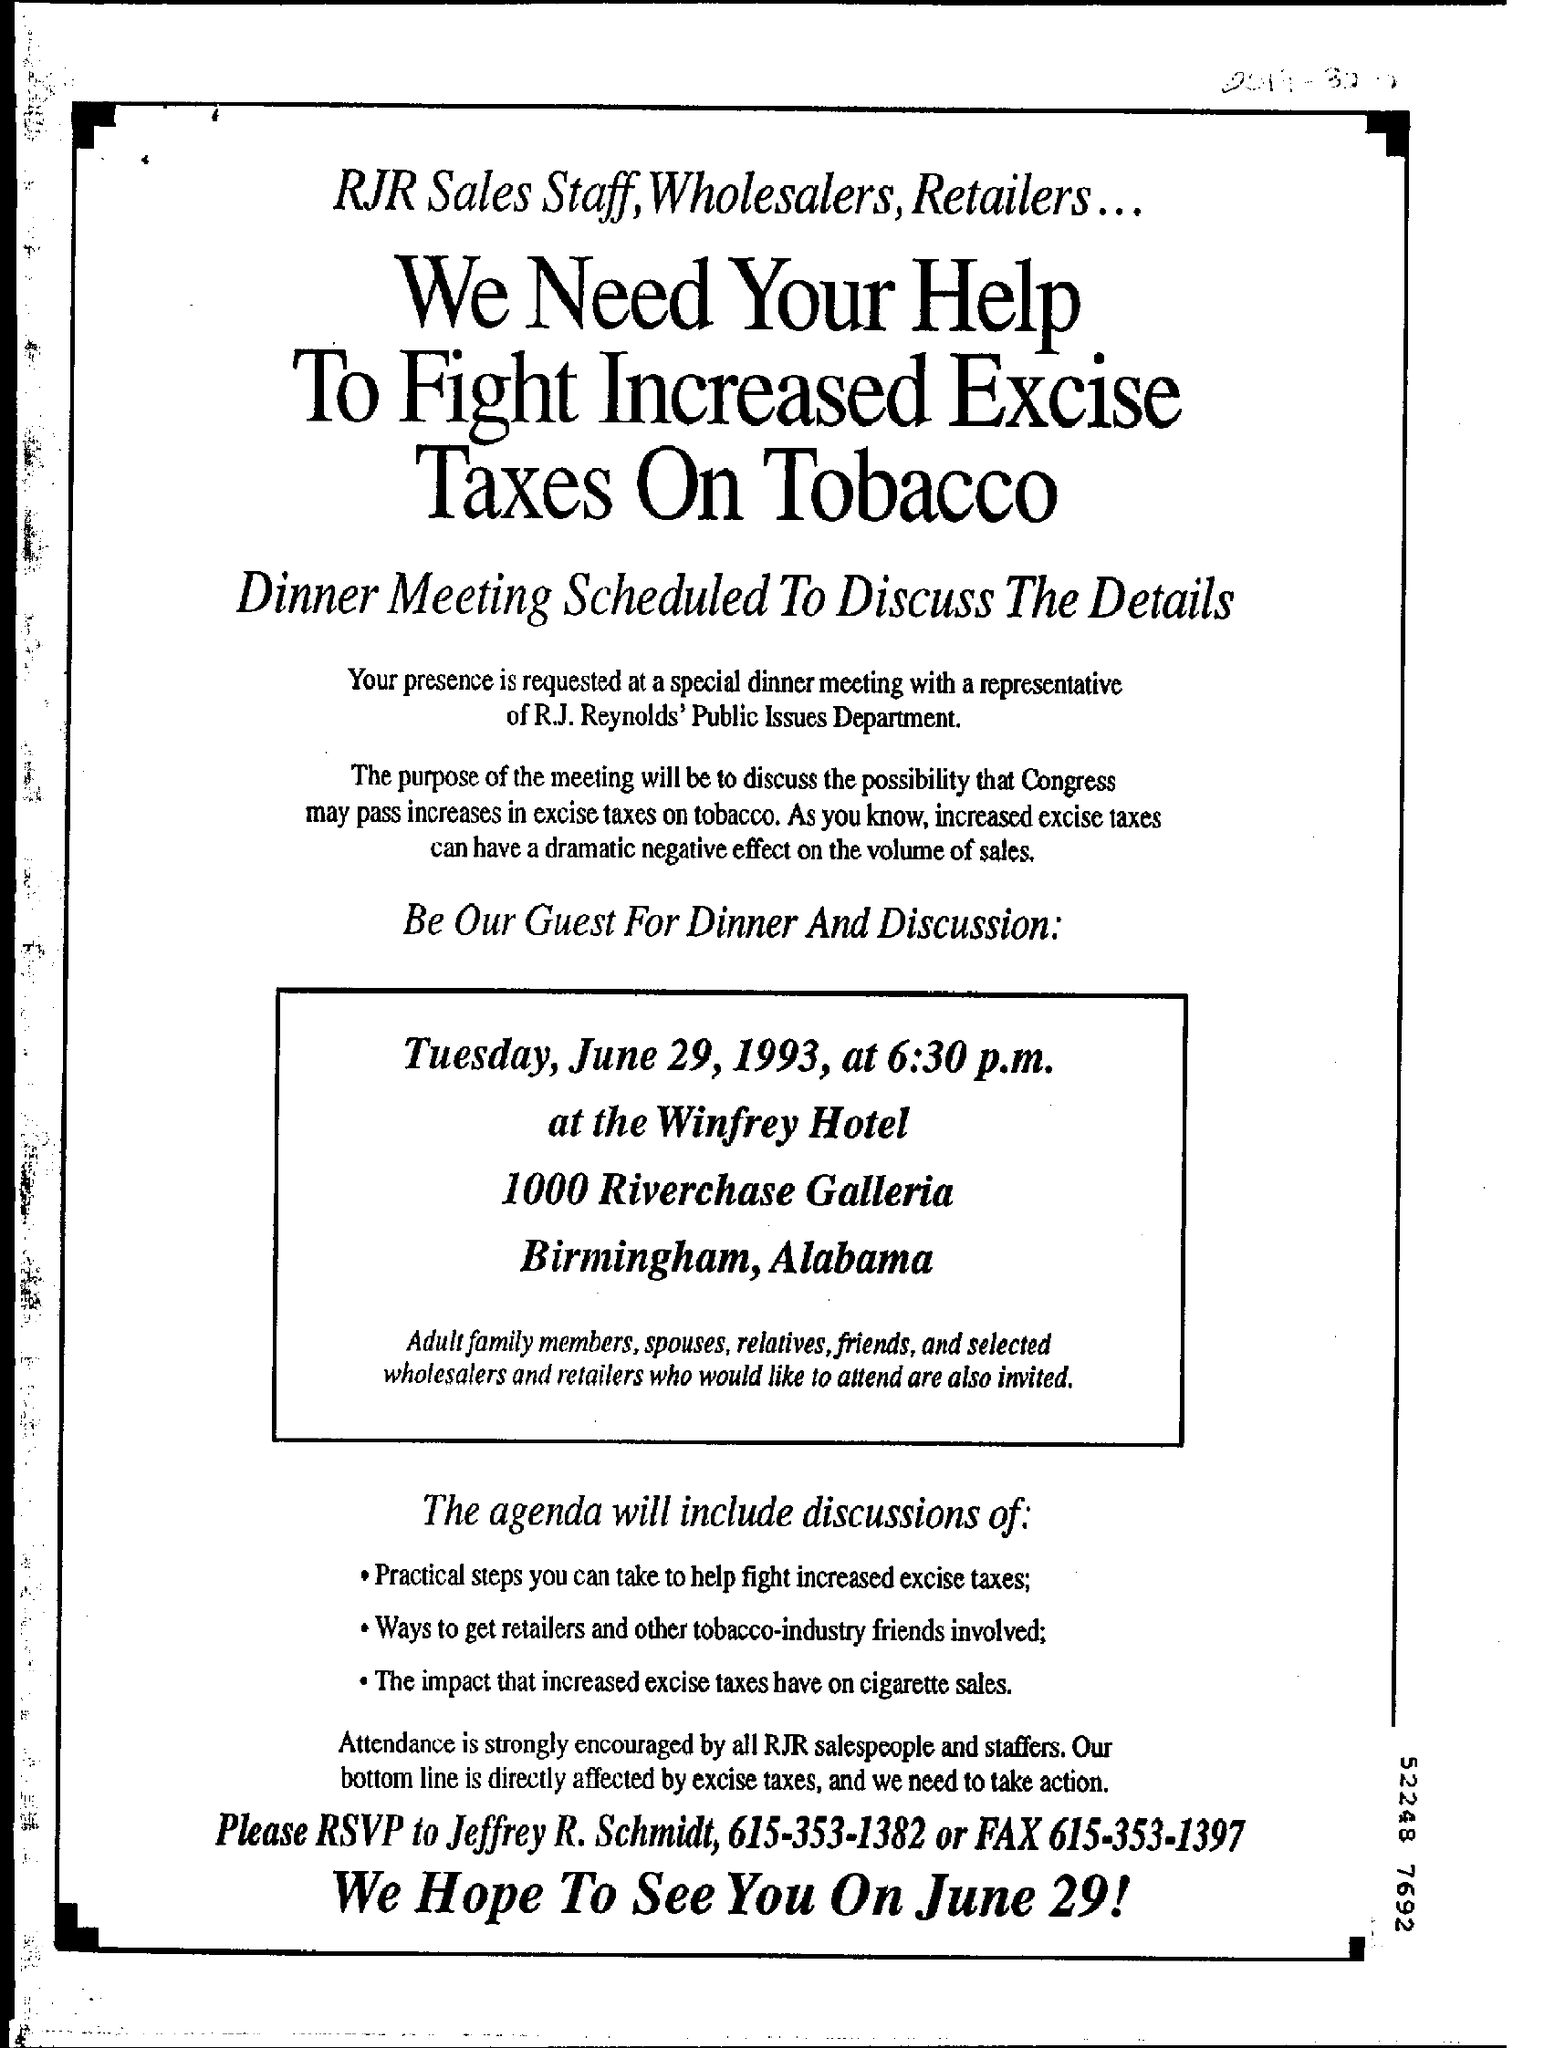Outline some significant characteristics in this image. The dinner and discussion is scheduled for 6:30 p.m. The RSVP is to be sent to Jeffrey R. Schmidt. 